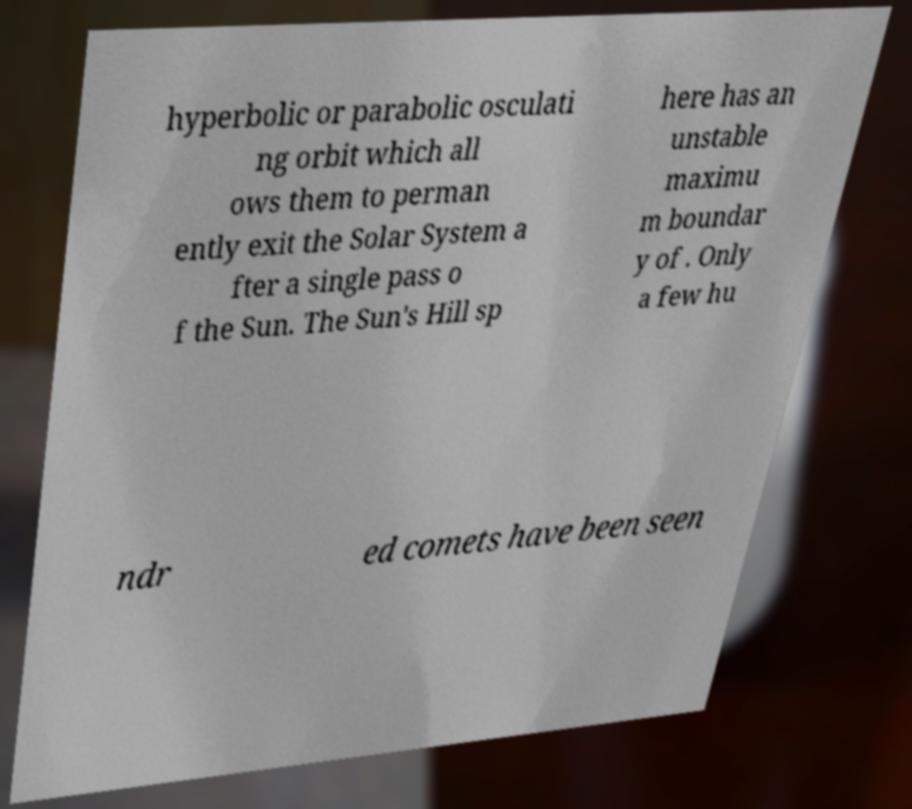Please read and relay the text visible in this image. What does it say? hyperbolic or parabolic osculati ng orbit which all ows them to perman ently exit the Solar System a fter a single pass o f the Sun. The Sun's Hill sp here has an unstable maximu m boundar y of . Only a few hu ndr ed comets have been seen 